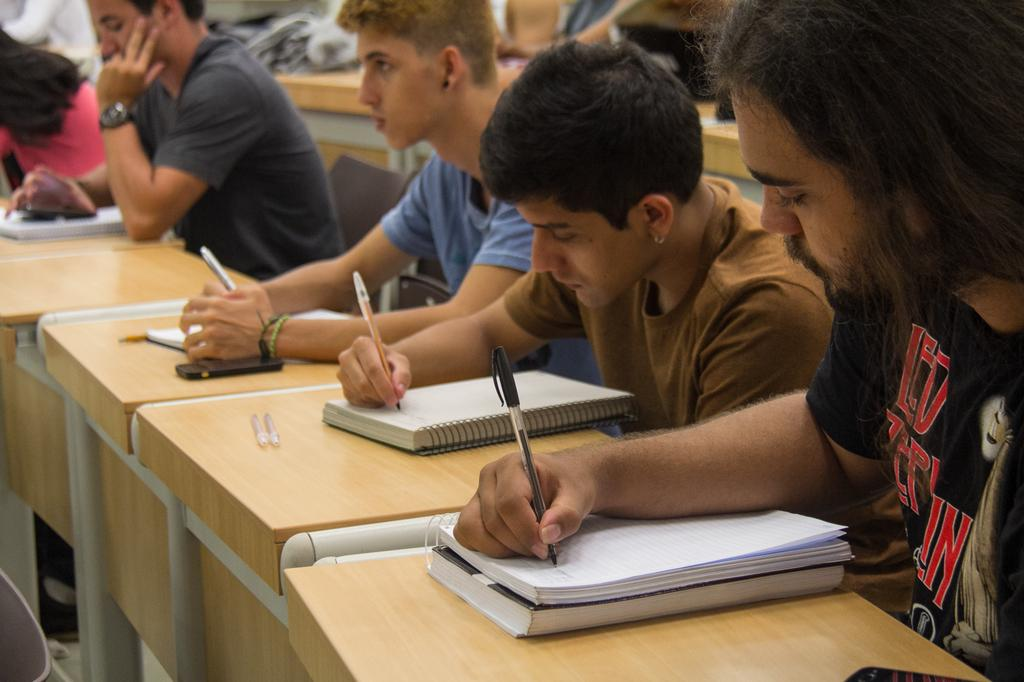<image>
Describe the image concisely. a shirt that has the name Led Zeppelin on it 